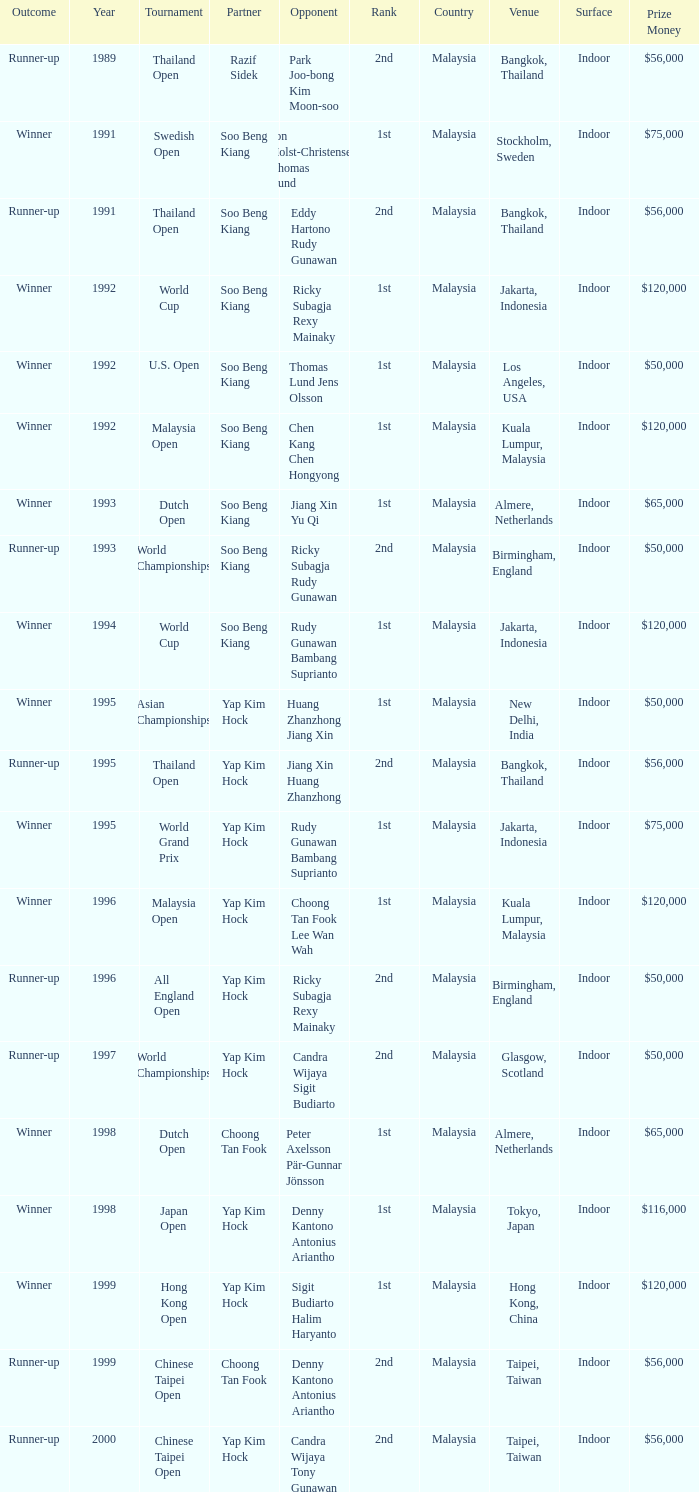Which opponent played in the Chinese Taipei Open in 2000? Candra Wijaya Tony Gunawan. 